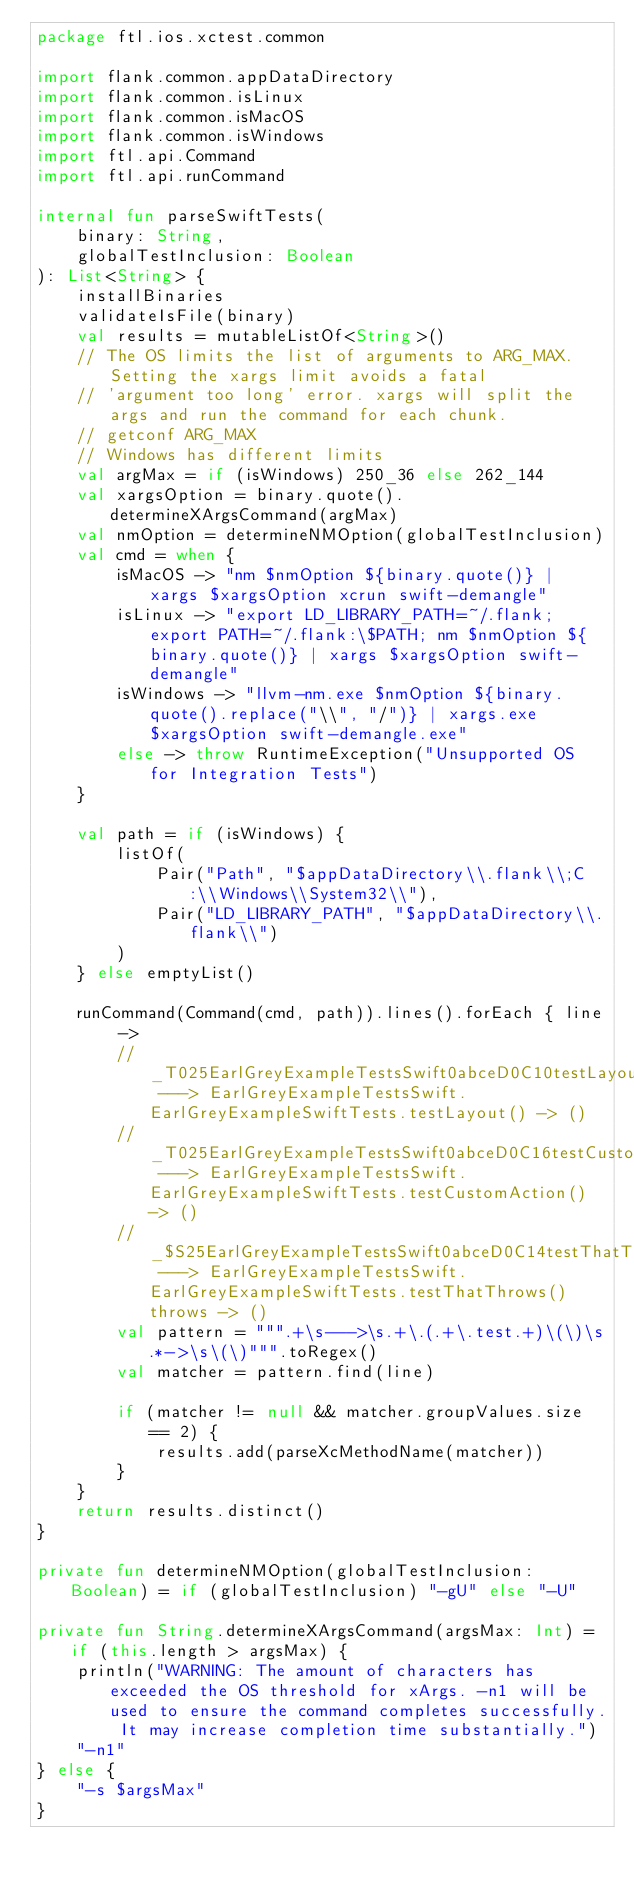Convert code to text. <code><loc_0><loc_0><loc_500><loc_500><_Kotlin_>package ftl.ios.xctest.common

import flank.common.appDataDirectory
import flank.common.isLinux
import flank.common.isMacOS
import flank.common.isWindows
import ftl.api.Command
import ftl.api.runCommand

internal fun parseSwiftTests(
    binary: String,
    globalTestInclusion: Boolean
): List<String> {
    installBinaries
    validateIsFile(binary)
    val results = mutableListOf<String>()
    // The OS limits the list of arguments to ARG_MAX. Setting the xargs limit avoids a fatal
    // 'argument too long' error. xargs will split the args and run the command for each chunk.
    // getconf ARG_MAX
    // Windows has different limits
    val argMax = if (isWindows) 250_36 else 262_144
    val xargsOption = binary.quote().determineXArgsCommand(argMax)
    val nmOption = determineNMOption(globalTestInclusion)
    val cmd = when {
        isMacOS -> "nm $nmOption ${binary.quote()} | xargs $xargsOption xcrun swift-demangle"
        isLinux -> "export LD_LIBRARY_PATH=~/.flank; export PATH=~/.flank:\$PATH; nm $nmOption ${binary.quote()} | xargs $xargsOption swift-demangle"
        isWindows -> "llvm-nm.exe $nmOption ${binary.quote().replace("\\", "/")} | xargs.exe $xargsOption swift-demangle.exe"
        else -> throw RuntimeException("Unsupported OS for Integration Tests")
    }

    val path = if (isWindows) {
        listOf(
            Pair("Path", "$appDataDirectory\\.flank\\;C:\\Windows\\System32\\"),
            Pair("LD_LIBRARY_PATH", "$appDataDirectory\\.flank\\")
        )
    } else emptyList()

    runCommand(Command(cmd, path)).lines().forEach { line ->
        // _T025EarlGreyExampleTestsSwift0abceD0C10testLayoutyyF ---> EarlGreyExampleTestsSwift.EarlGreyExampleSwiftTests.testLayout() -> ()
        // _T025EarlGreyExampleTestsSwift0abceD0C16testCustomActionyyF ---> EarlGreyExampleTestsSwift.EarlGreyExampleSwiftTests.testCustomAction() -> ()
        // _$S25EarlGreyExampleTestsSwift0abceD0C14testThatThrowsyyKF ---> EarlGreyExampleTestsSwift.EarlGreyExampleSwiftTests.testThatThrows() throws -> ()
        val pattern = """.+\s--->\s.+\.(.+\.test.+)\(\)\s.*->\s\(\)""".toRegex()
        val matcher = pattern.find(line)

        if (matcher != null && matcher.groupValues.size == 2) {
            results.add(parseXcMethodName(matcher))
        }
    }
    return results.distinct()
}

private fun determineNMOption(globalTestInclusion: Boolean) = if (globalTestInclusion) "-gU" else "-U"

private fun String.determineXArgsCommand(argsMax: Int) = if (this.length > argsMax) {
    println("WARNING: The amount of characters has exceeded the OS threshold for xArgs. -n1 will be used to ensure the command completes successfully. It may increase completion time substantially.")
    "-n1"
} else {
    "-s $argsMax"
}
</code> 